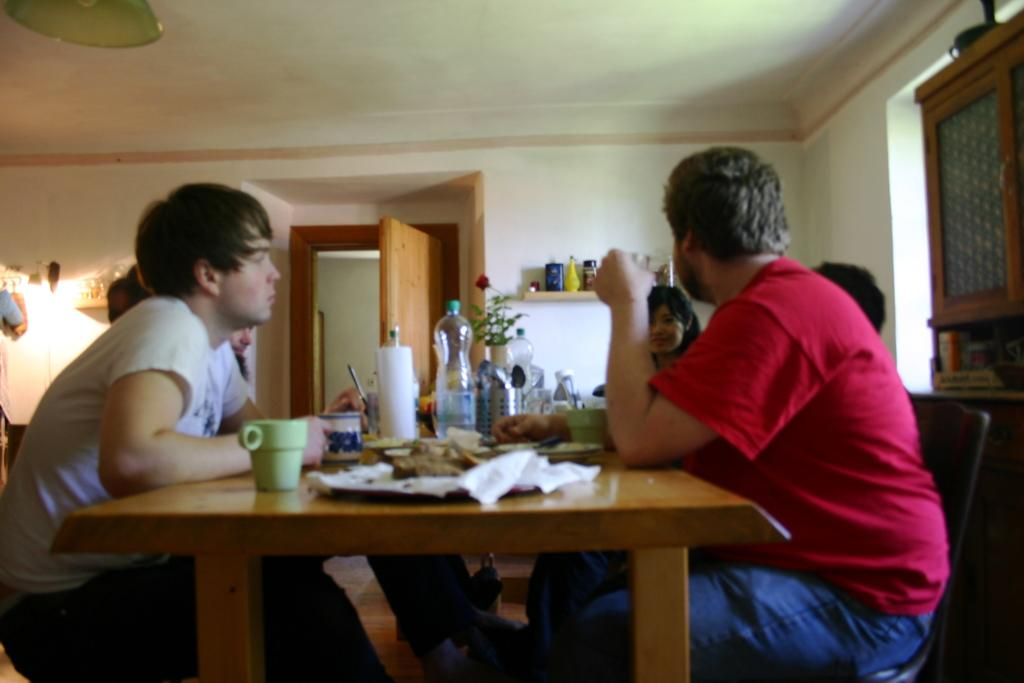How many people are in the image? There is a group of people in the image. What are the people doing in the image? The people are seated in front of a dining table. What objects can be seen on the table? There are bottles, cups, and plates on the table. Can you see any snails crawling on the plates in the image? There are no snails present in the image; it only shows a group of people seated at a dining table with bottles, cups, and plates. 